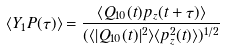<formula> <loc_0><loc_0><loc_500><loc_500>\langle Y _ { 1 } P ( \tau ) \rangle = \frac { \langle Q _ { 1 0 } ( t ) p _ { z } ( t + \tau ) \rangle } { ( \langle | Q _ { 1 0 } ( t ) | ^ { 2 } \rangle \langle p ^ { 2 } _ { z } ( t ) \rangle ) ^ { 1 / 2 } }</formula> 